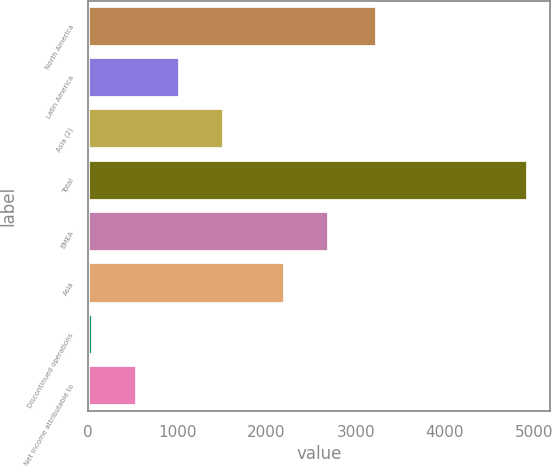Convert chart. <chart><loc_0><loc_0><loc_500><loc_500><bar_chart><fcel>North America<fcel>Latin America<fcel>Asia (2)<fcel>Total<fcel>EMEA<fcel>Asia<fcel>Discontinued operations<fcel>Net income attributable to<nl><fcel>3239<fcel>1032.6<fcel>1519.9<fcel>4931<fcel>2698.3<fcel>2211<fcel>58<fcel>545.3<nl></chart> 